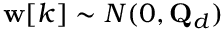<formula> <loc_0><loc_0><loc_500><loc_500>w [ k ] \sim N ( 0 , Q _ { d } )</formula> 